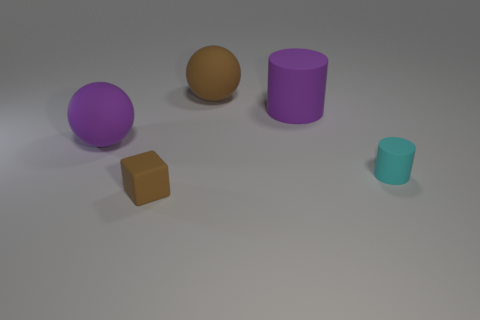Add 5 tiny matte objects. How many objects exist? 10 Subtract all cubes. How many objects are left? 4 Subtract all brown cubes. How many purple cylinders are left? 1 Subtract all purple cylinders. Subtract all tiny red matte cubes. How many objects are left? 4 Add 3 small cylinders. How many small cylinders are left? 4 Add 4 big purple objects. How many big purple objects exist? 6 Subtract 0 red cylinders. How many objects are left? 5 Subtract 1 spheres. How many spheres are left? 1 Subtract all red balls. Subtract all yellow blocks. How many balls are left? 2 